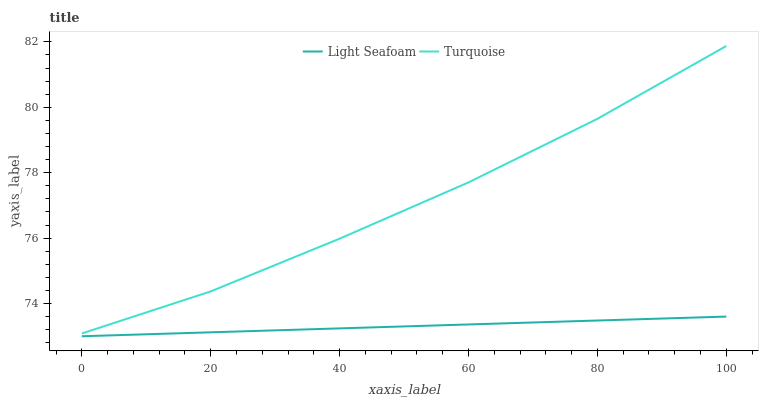Does Light Seafoam have the minimum area under the curve?
Answer yes or no. Yes. Does Turquoise have the maximum area under the curve?
Answer yes or no. Yes. Does Light Seafoam have the maximum area under the curve?
Answer yes or no. No. Is Light Seafoam the smoothest?
Answer yes or no. Yes. Is Turquoise the roughest?
Answer yes or no. Yes. Is Light Seafoam the roughest?
Answer yes or no. No. Does Light Seafoam have the lowest value?
Answer yes or no. Yes. Does Turquoise have the highest value?
Answer yes or no. Yes. Does Light Seafoam have the highest value?
Answer yes or no. No. Is Light Seafoam less than Turquoise?
Answer yes or no. Yes. Is Turquoise greater than Light Seafoam?
Answer yes or no. Yes. Does Light Seafoam intersect Turquoise?
Answer yes or no. No. 